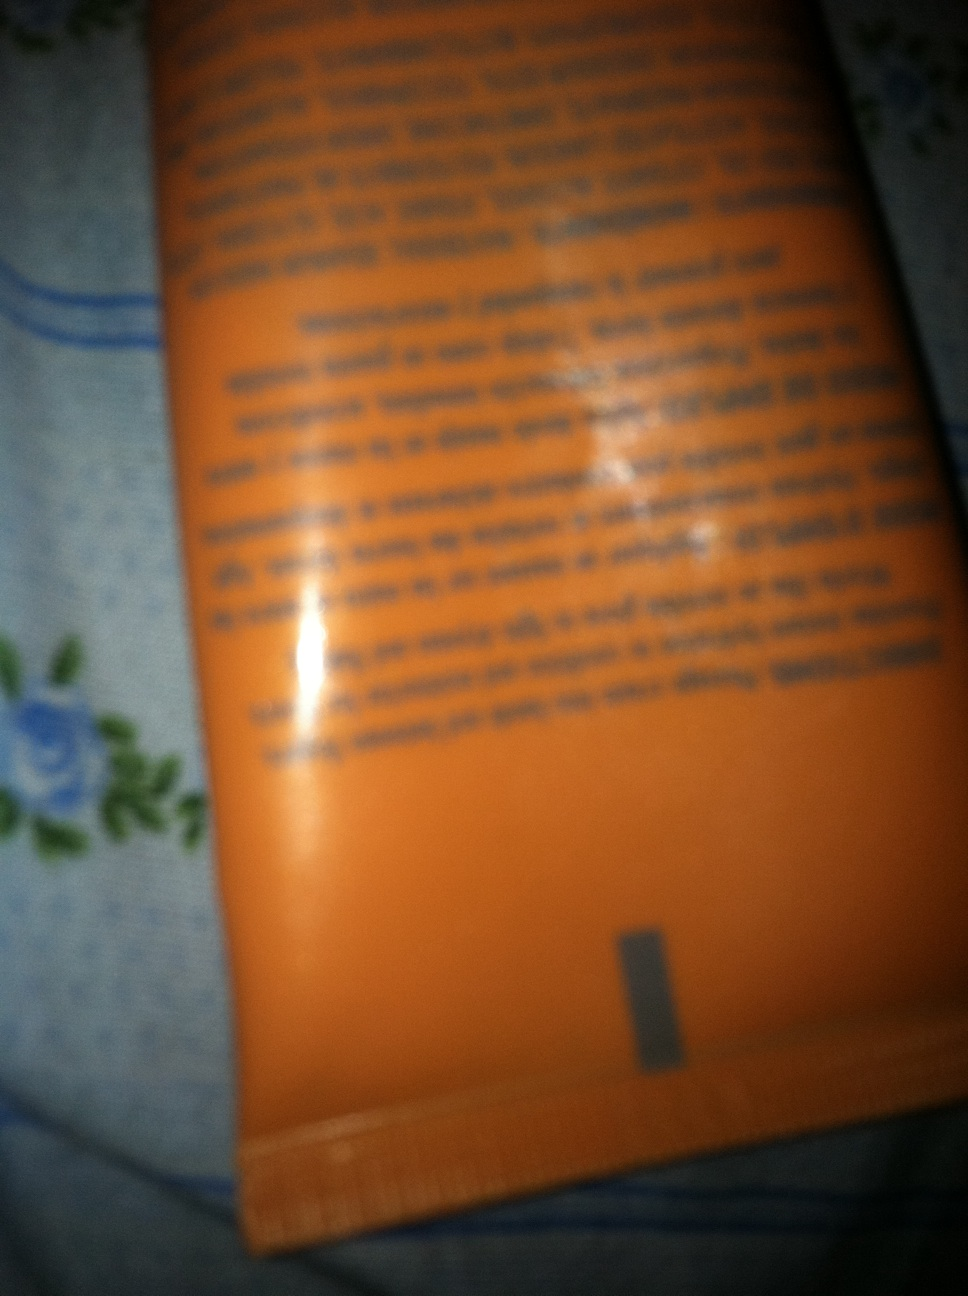Can you help identify the brand or any visible text on this tube? The image is quite blurry, making it difficult to identify specific text or brand names. Enhancing the lighting or providing a closer, more focused picture might help in identifying the details. 